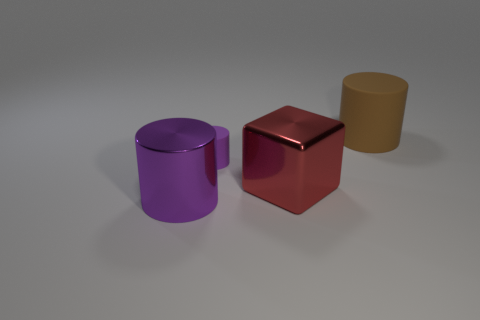There is a purple cylinder behind the big purple cylinder; are there any matte cylinders right of it?
Provide a succinct answer. Yes. How many other things are the same color as the tiny matte cylinder?
Make the answer very short. 1. The metal block has what size?
Make the answer very short. Large. Is there a large purple shiny cylinder?
Your answer should be very brief. Yes. Are there more tiny purple matte things on the right side of the tiny cylinder than big purple metallic objects that are in front of the red metallic thing?
Offer a very short reply. No. There is a thing that is on the left side of the large cube and in front of the tiny purple object; what material is it?
Your answer should be compact. Metal. Is the shape of the large brown object the same as the small purple matte object?
Your answer should be compact. Yes. Is there any other thing that is the same size as the red block?
Offer a terse response. Yes. How many small purple rubber objects are in front of the shiny cylinder?
Offer a very short reply. 0. Does the matte thing in front of the brown matte thing have the same size as the red thing?
Ensure brevity in your answer.  No. 